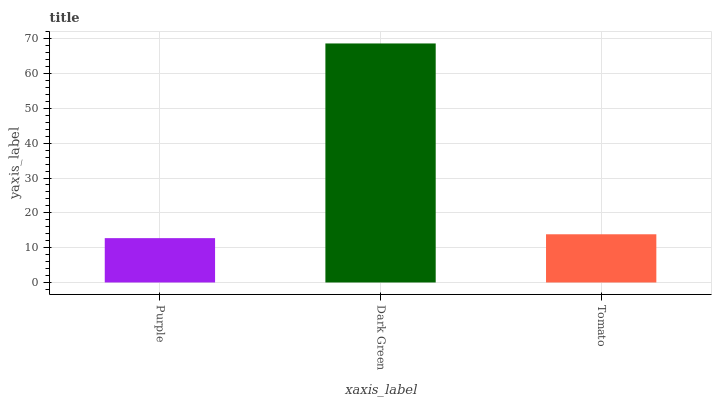Is Purple the minimum?
Answer yes or no. Yes. Is Dark Green the maximum?
Answer yes or no. Yes. Is Tomato the minimum?
Answer yes or no. No. Is Tomato the maximum?
Answer yes or no. No. Is Dark Green greater than Tomato?
Answer yes or no. Yes. Is Tomato less than Dark Green?
Answer yes or no. Yes. Is Tomato greater than Dark Green?
Answer yes or no. No. Is Dark Green less than Tomato?
Answer yes or no. No. Is Tomato the high median?
Answer yes or no. Yes. Is Tomato the low median?
Answer yes or no. Yes. Is Purple the high median?
Answer yes or no. No. Is Purple the low median?
Answer yes or no. No. 